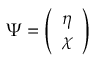<formula> <loc_0><loc_0><loc_500><loc_500>\Psi = \left ( \begin{array} { l } { \eta } \\ { \chi } \end{array} \right )</formula> 